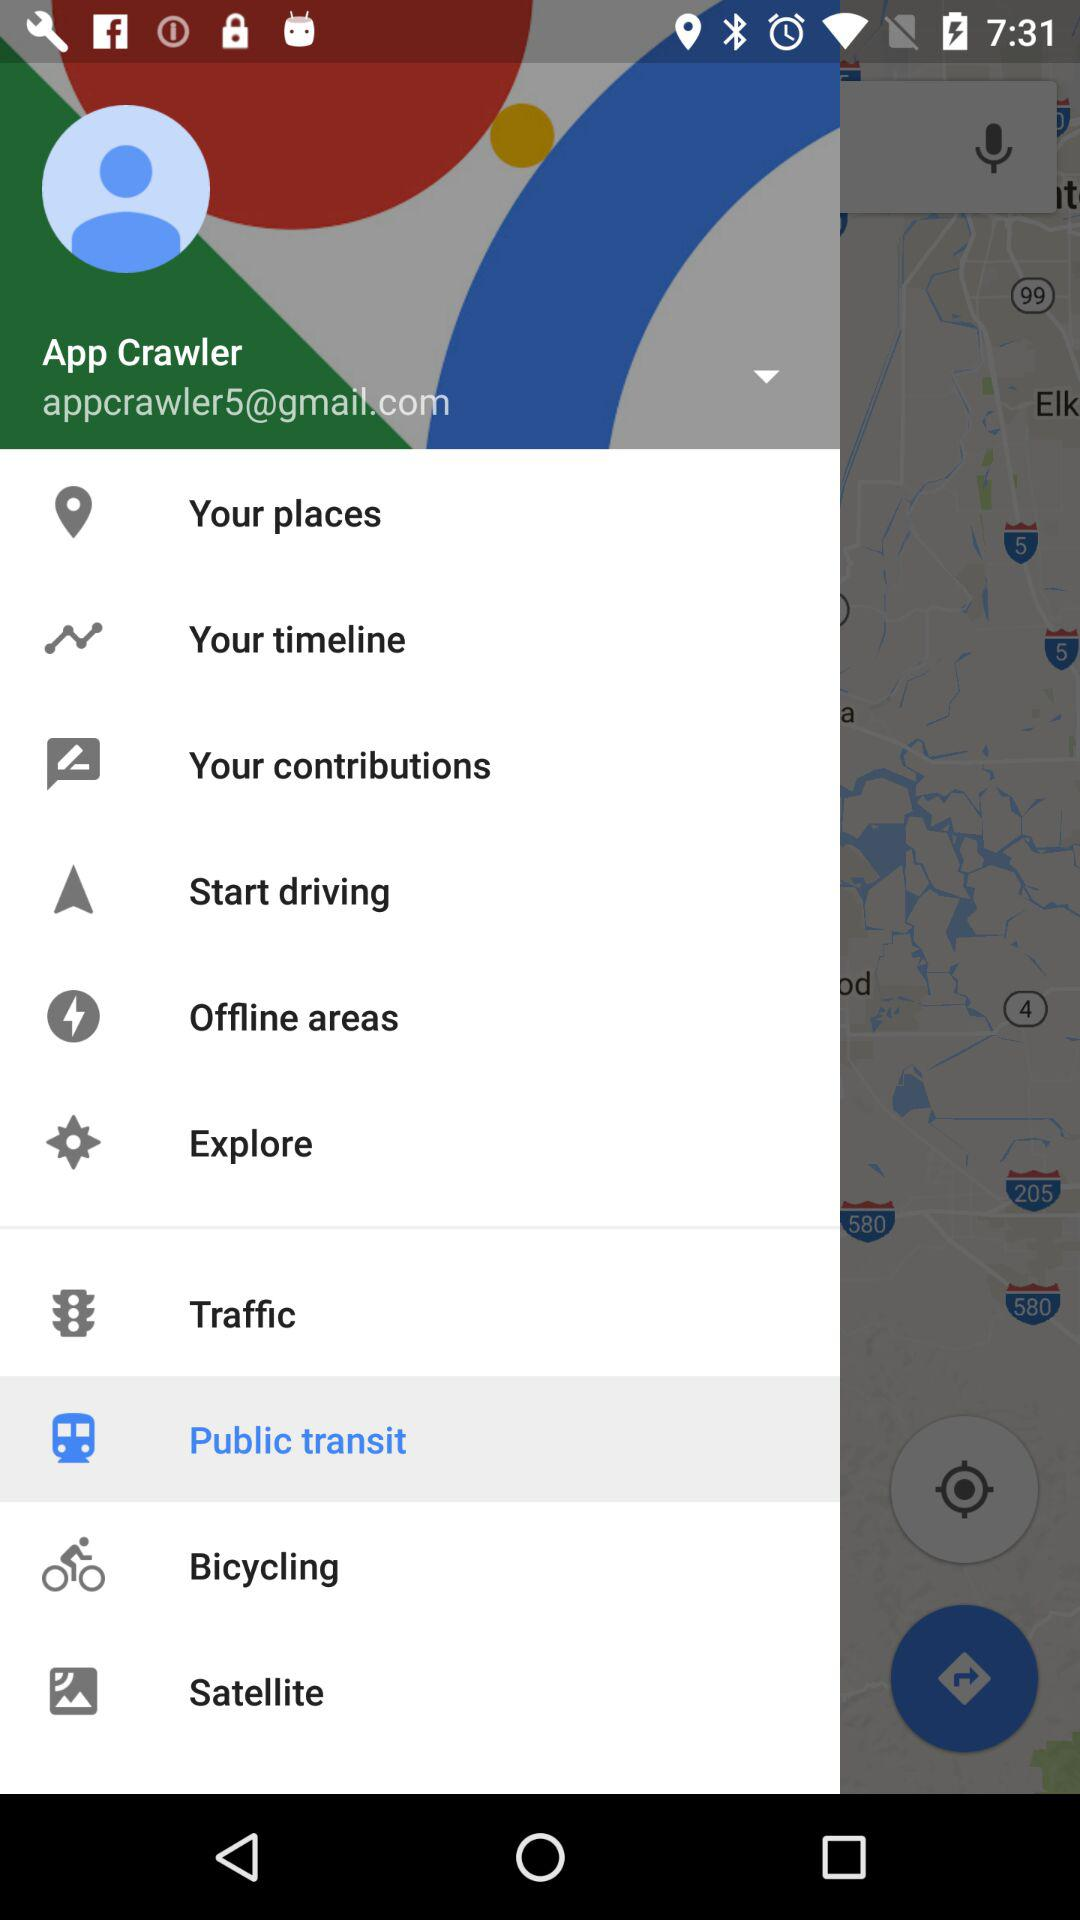What is the name? The name is App Crawler. 